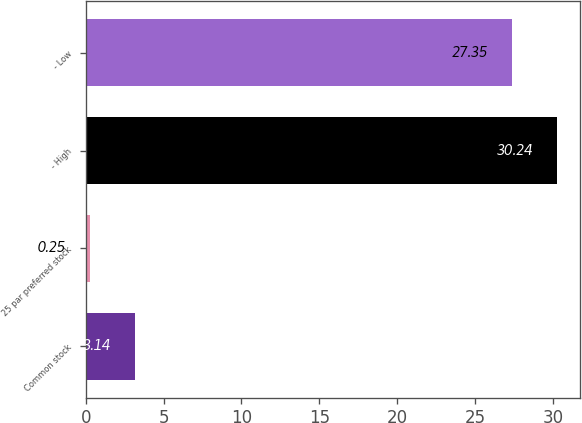<chart> <loc_0><loc_0><loc_500><loc_500><bar_chart><fcel>Common stock<fcel>25 par preferred stock<fcel>- High<fcel>- Low<nl><fcel>3.14<fcel>0.25<fcel>30.24<fcel>27.35<nl></chart> 